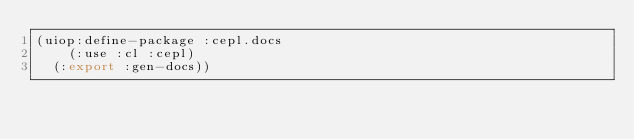<code> <loc_0><loc_0><loc_500><loc_500><_Lisp_>(uiop:define-package :cepl.docs
    (:use :cl :cepl)
  (:export :gen-docs))
</code> 